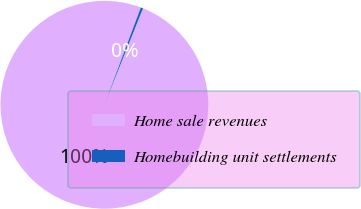Convert chart to OTSL. <chart><loc_0><loc_0><loc_500><loc_500><pie_chart><fcel>Home sale revenues<fcel>Homebuilding unit settlements<nl><fcel>99.65%<fcel>0.35%<nl></chart> 